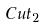<formula> <loc_0><loc_0><loc_500><loc_500>C u t _ { 2 }</formula> 